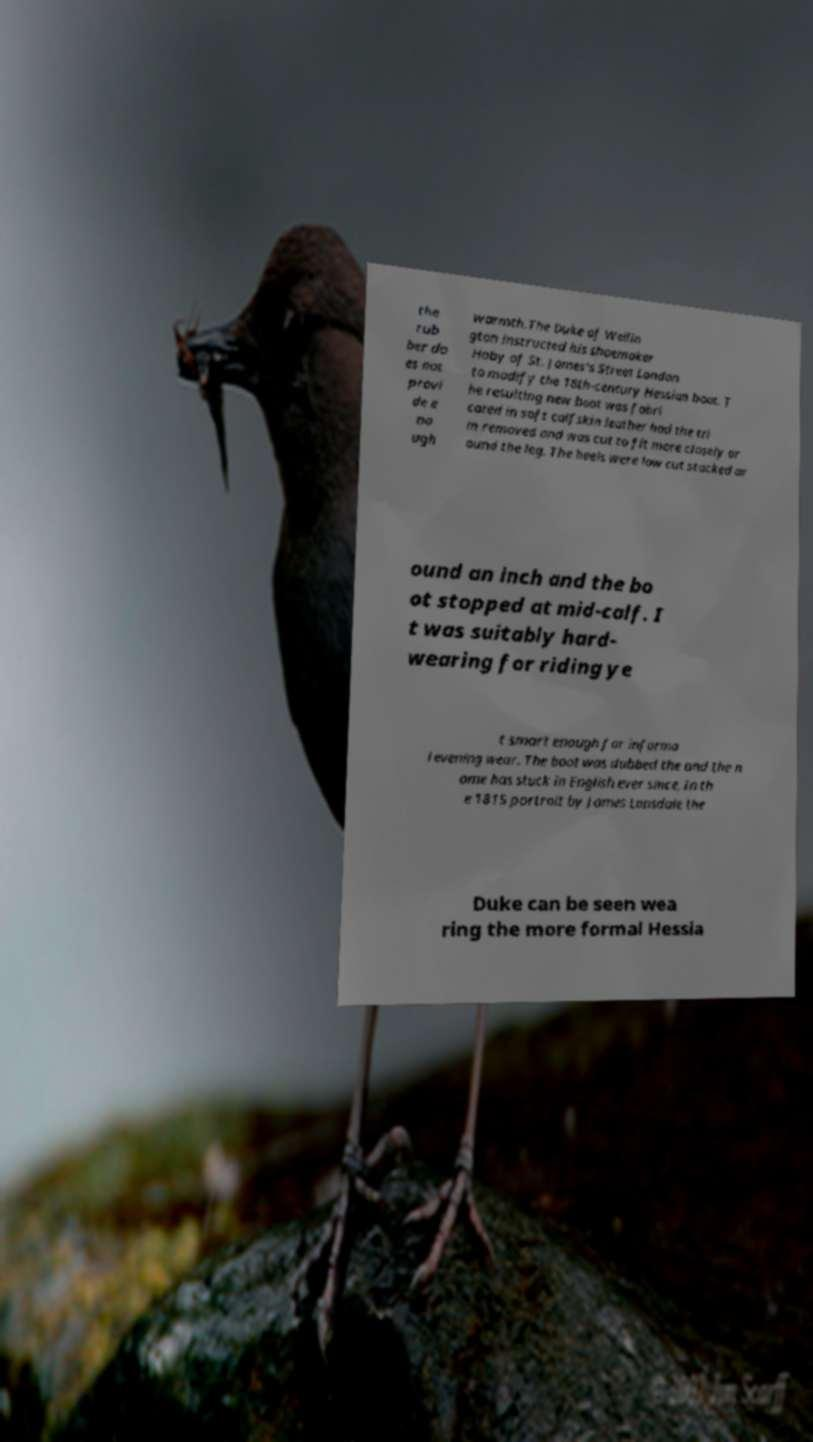Can you accurately transcribe the text from the provided image for me? the rub ber do es not provi de e no ugh warmth.The Duke of Wellin gton instructed his shoemaker Hoby of St. James's Street London to modify the 18th-century Hessian boot. T he resulting new boot was fabri cated in soft calfskin leather had the tri m removed and was cut to fit more closely ar ound the leg. The heels were low cut stacked ar ound an inch and the bo ot stopped at mid-calf. I t was suitably hard- wearing for riding ye t smart enough for informa l evening wear. The boot was dubbed the and the n ame has stuck in English ever since. In th e 1815 portrait by James Lonsdale the Duke can be seen wea ring the more formal Hessia 